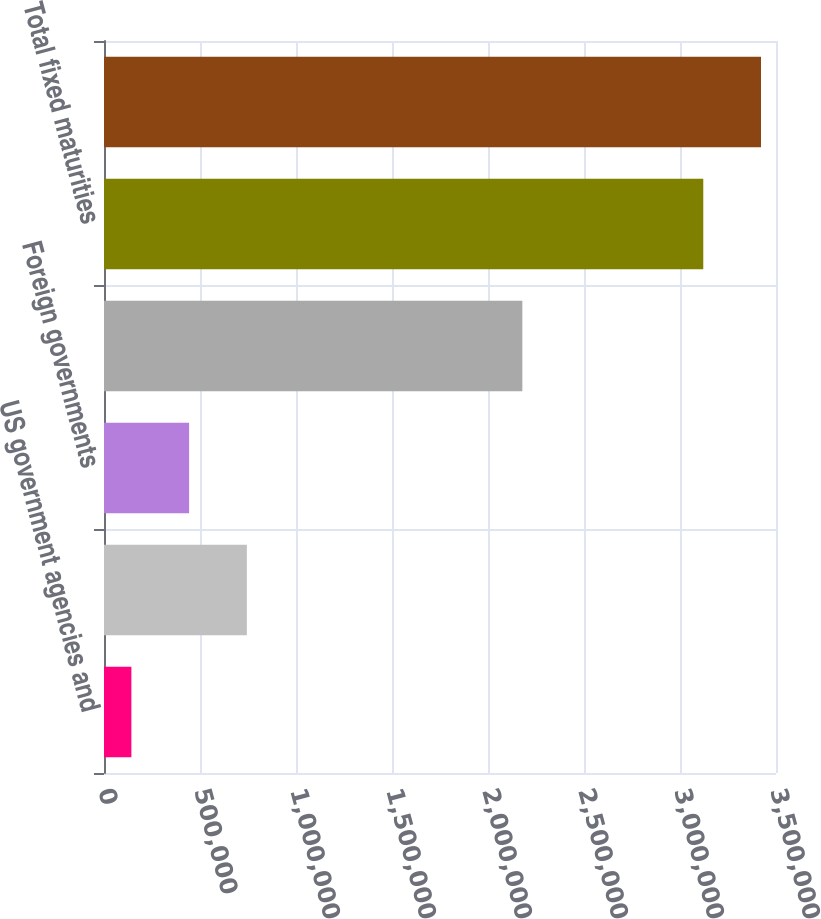Convert chart to OTSL. <chart><loc_0><loc_0><loc_500><loc_500><bar_chart><fcel>US government agencies and<fcel>States municipalities and<fcel>Foreign governments<fcel>All other corporate<fcel>Total fixed maturities<fcel>Total<nl><fcel>142625<fcel>743936<fcel>443280<fcel>2.17893e+06<fcel>3.12124e+06<fcel>3.42189e+06<nl></chart> 